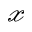<formula> <loc_0><loc_0><loc_500><loc_500>\mathcal { x }</formula> 